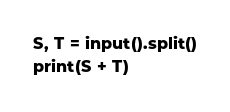Convert code to text. <code><loc_0><loc_0><loc_500><loc_500><_Python_>S, T = input().split()
print(S + T)</code> 